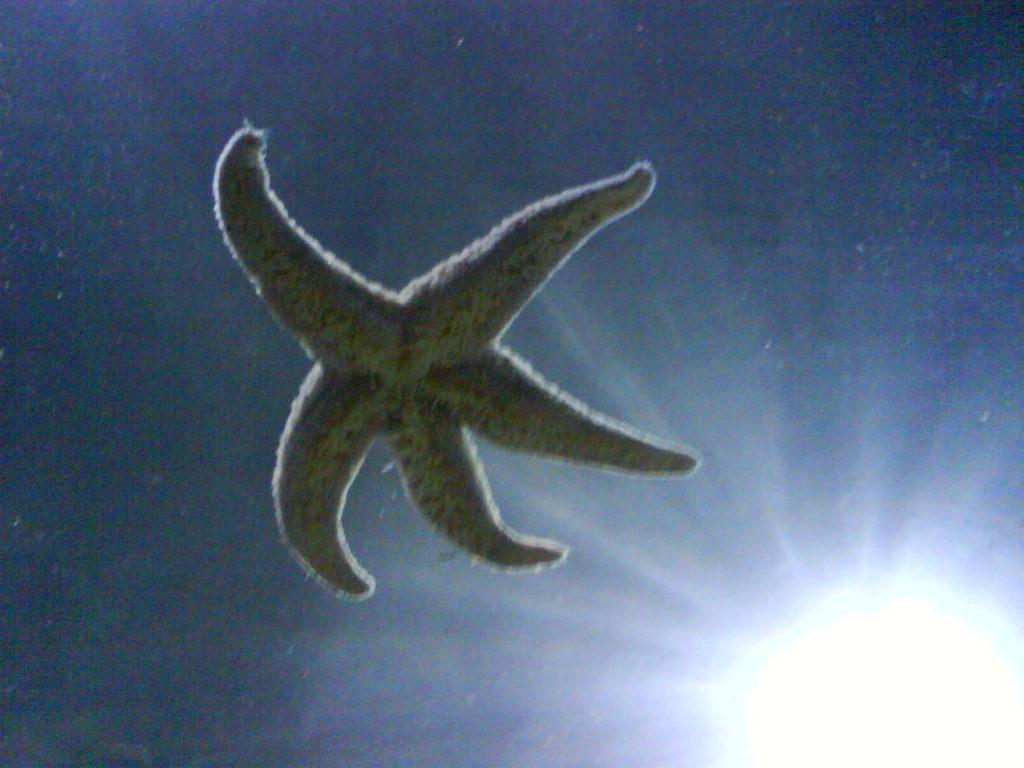What type of sea creature is in the image? There is a starfish in the image. What can be seen illuminating the scene in the image? There is a light in the image. What type of snack is being served in the image? There is no snack visible in the image; it only features a starfish and a light. 